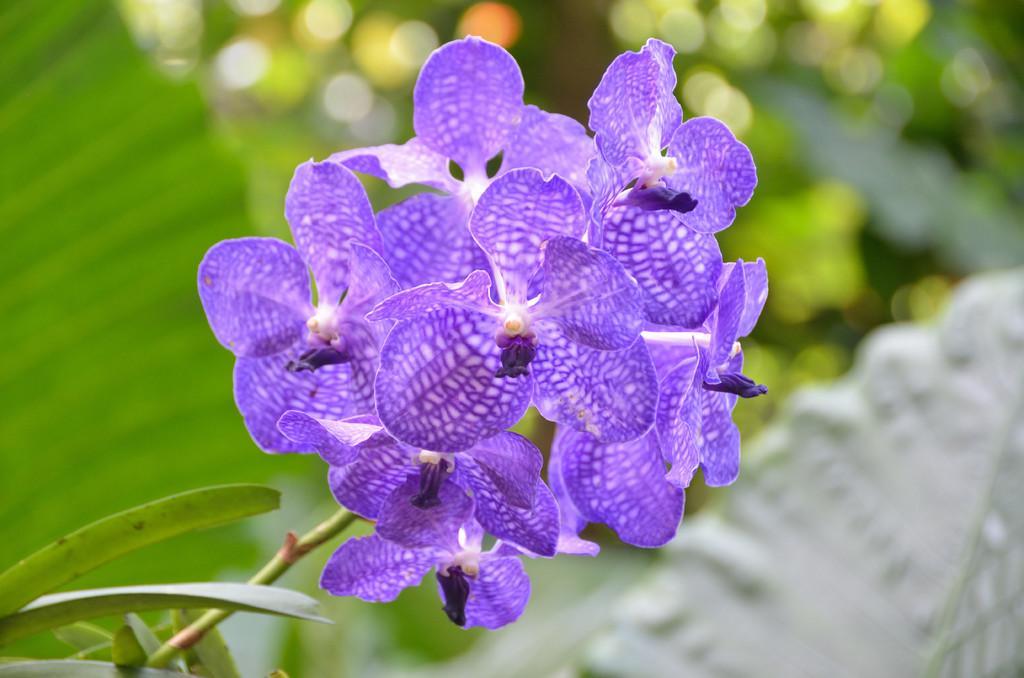In one or two sentences, can you explain what this image depicts? In the picture I can see group of flowers to the plants, behind we can see some leaves. 